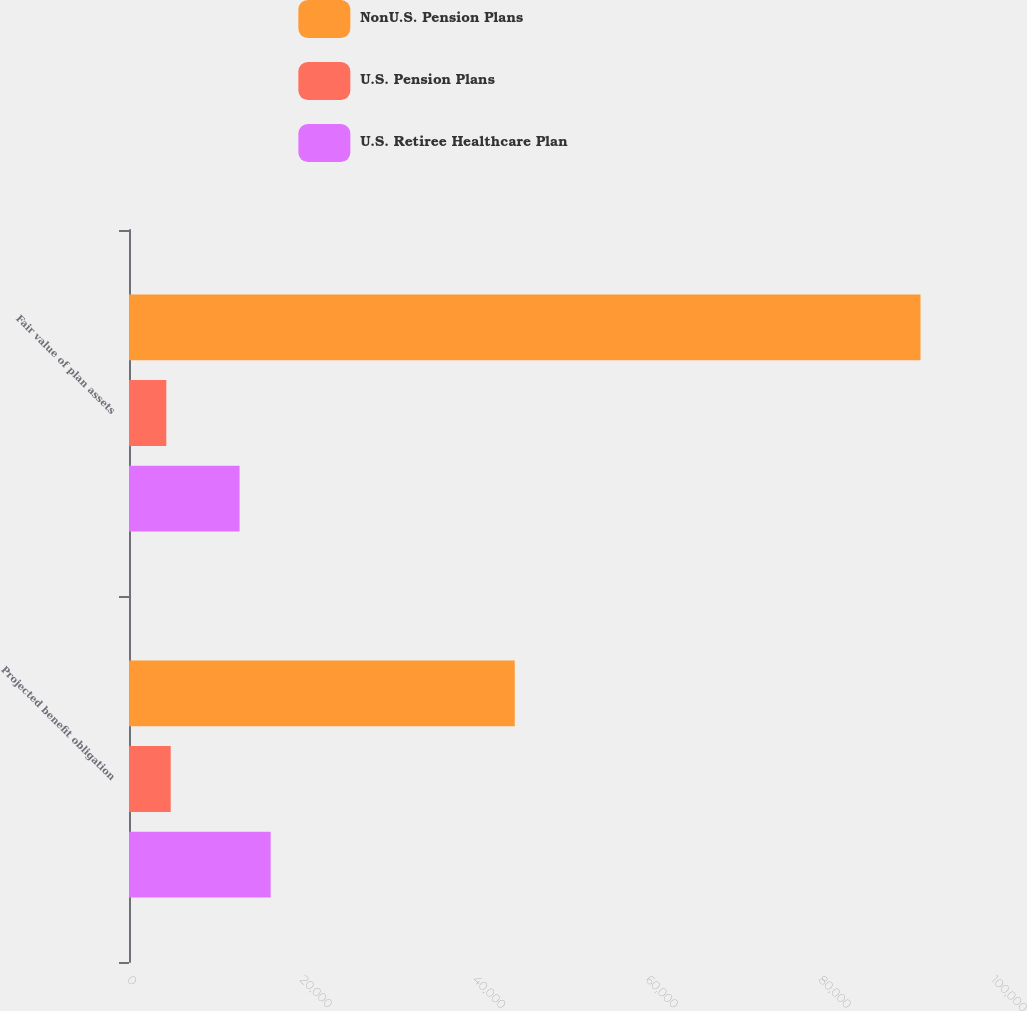Convert chart. <chart><loc_0><loc_0><loc_500><loc_500><stacked_bar_chart><ecel><fcel>Projected benefit obligation<fcel>Fair value of plan assets<nl><fcel>NonU.S. Pension Plans<fcel>44646<fcel>91610<nl><fcel>U.S. Pension Plans<fcel>4827<fcel>4319<nl><fcel>U.S. Retiree Healthcare Plan<fcel>16397<fcel>12798<nl></chart> 